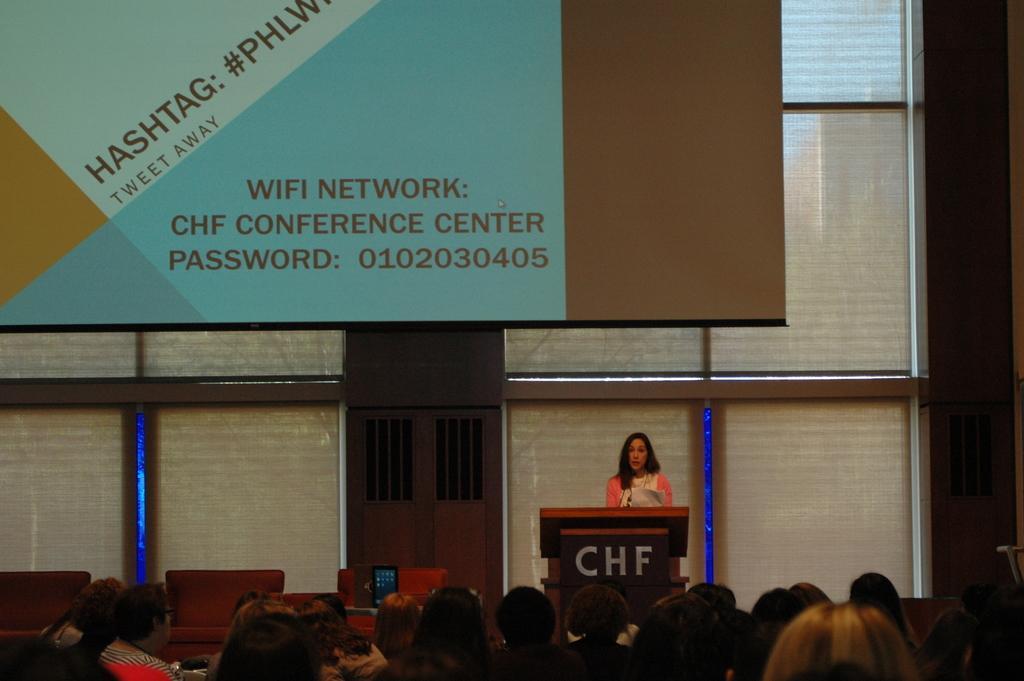Can you describe this image briefly? At the bottom of this image I can see many people facing towards the back side. In the background there is a woman standing in front of the podium and speaking on the microphone. At the top of the image there is a board attached to the wall. On the board, I can see some text. 